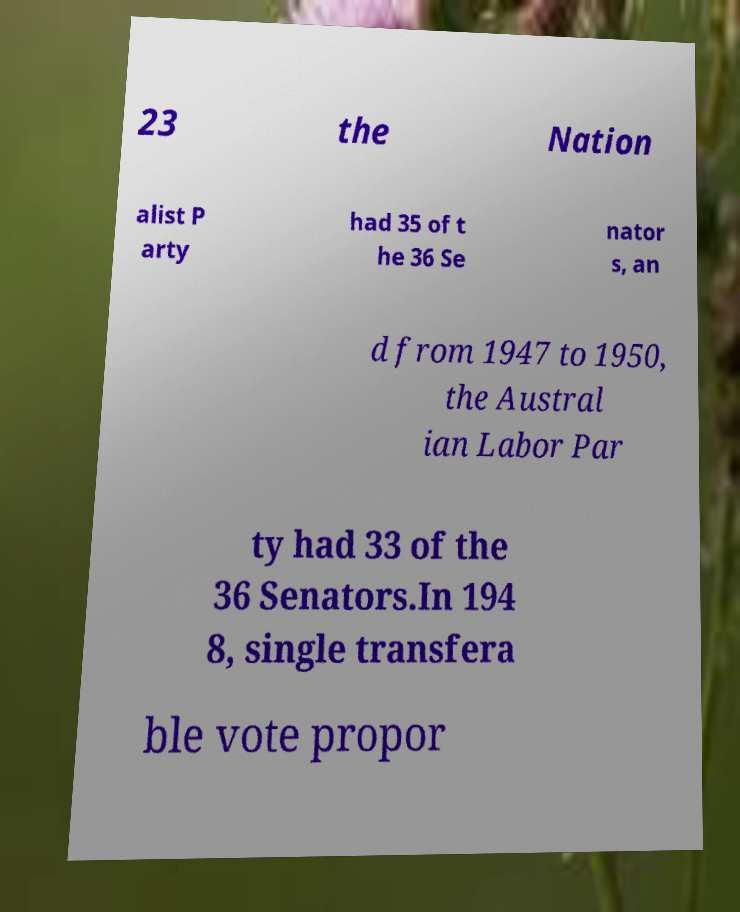Can you read and provide the text displayed in the image?This photo seems to have some interesting text. Can you extract and type it out for me? 23 the Nation alist P arty had 35 of t he 36 Se nator s, an d from 1947 to 1950, the Austral ian Labor Par ty had 33 of the 36 Senators.In 194 8, single transfera ble vote propor 